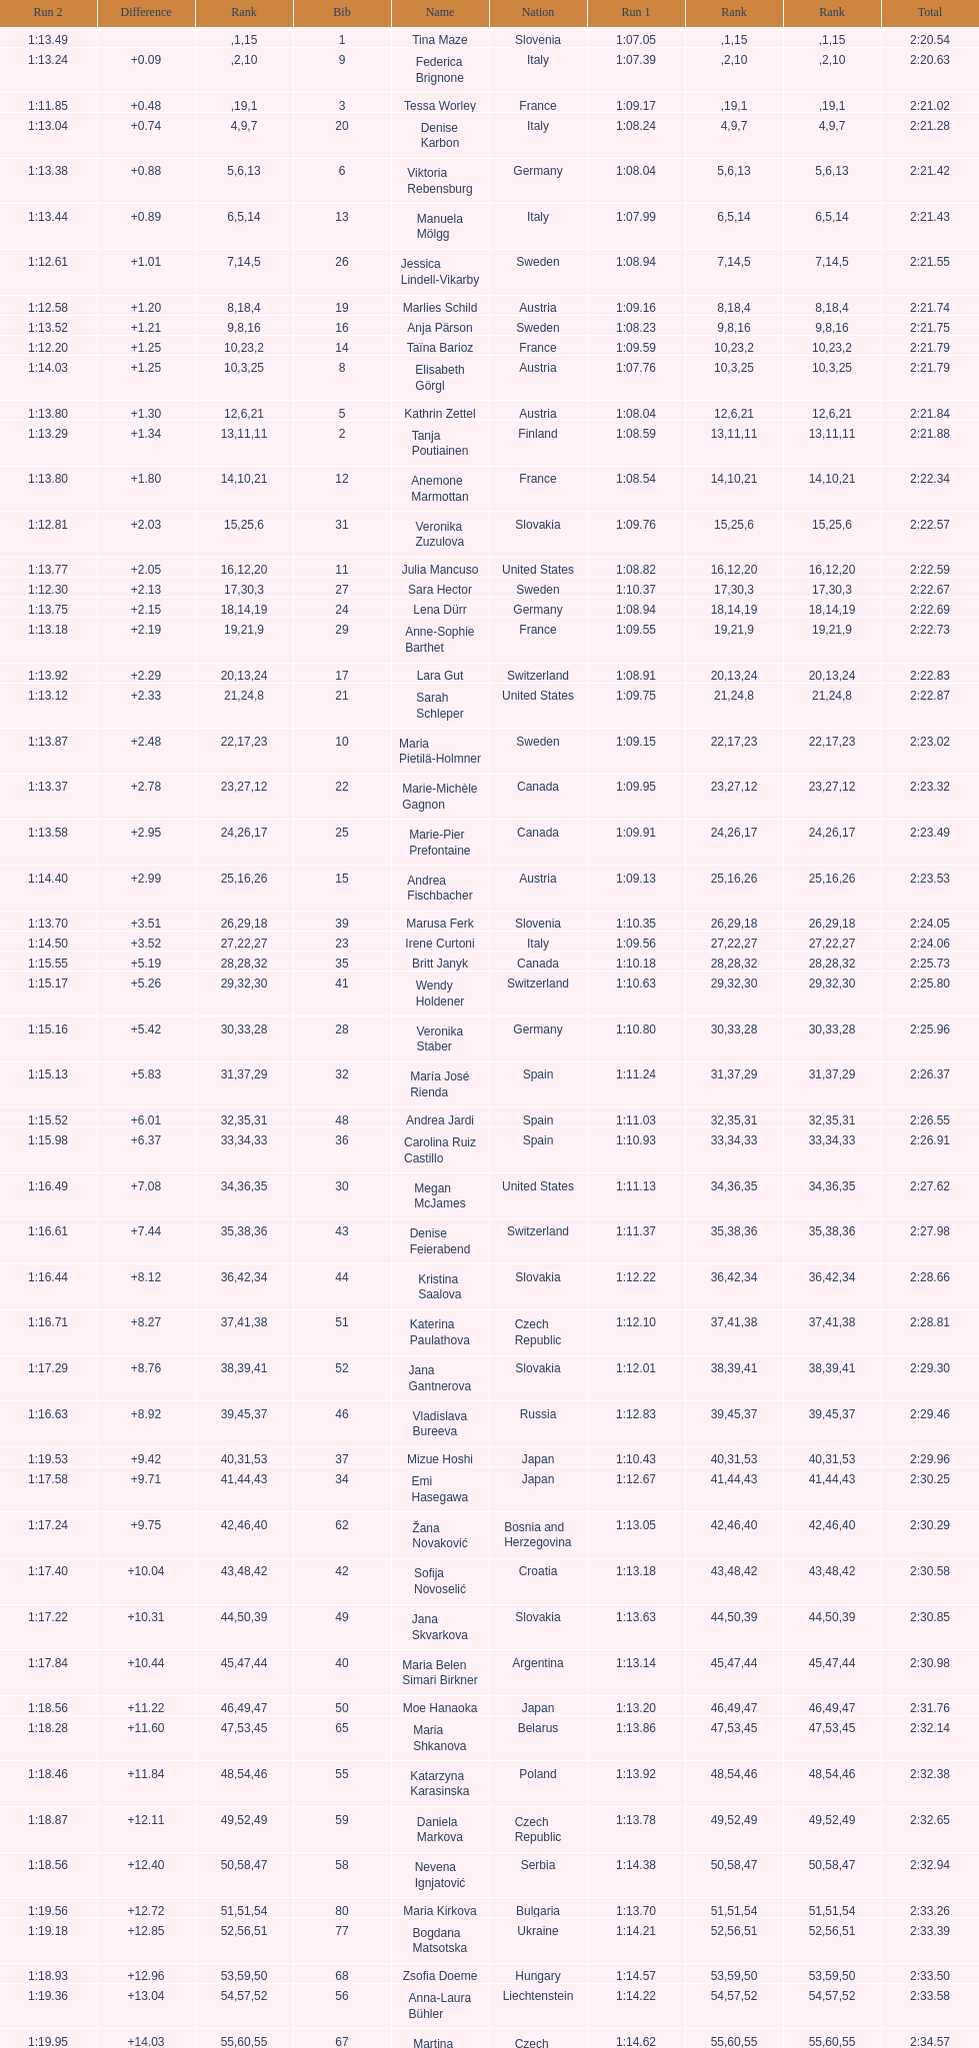What is the last nation to be ranked? Czech Republic. Parse the table in full. {'header': ['Run 2', 'Difference', 'Rank', 'Bib', 'Name', 'Nation', 'Run 1', 'Rank', 'Rank', 'Total'], 'rows': [['1:13.49', '', '', '1', 'Tina Maze', 'Slovenia', '1:07.05', '1', '15', '2:20.54'], ['1:13.24', '+0.09', '', '9', 'Federica Brignone', 'Italy', '1:07.39', '2', '10', '2:20.63'], ['1:11.85', '+0.48', '', '3', 'Tessa Worley', 'France', '1:09.17', '19', '1', '2:21.02'], ['1:13.04', '+0.74', '4', '20', 'Denise Karbon', 'Italy', '1:08.24', '9', '7', '2:21.28'], ['1:13.38', '+0.88', '5', '6', 'Viktoria Rebensburg', 'Germany', '1:08.04', '6', '13', '2:21.42'], ['1:13.44', '+0.89', '6', '13', 'Manuela Mölgg', 'Italy', '1:07.99', '5', '14', '2:21.43'], ['1:12.61', '+1.01', '7', '26', 'Jessica Lindell-Vikarby', 'Sweden', '1:08.94', '14', '5', '2:21.55'], ['1:12.58', '+1.20', '8', '19', 'Marlies Schild', 'Austria', '1:09.16', '18', '4', '2:21.74'], ['1:13.52', '+1.21', '9', '16', 'Anja Pärson', 'Sweden', '1:08.23', '8', '16', '2:21.75'], ['1:12.20', '+1.25', '10', '14', 'Taïna Barioz', 'France', '1:09.59', '23', '2', '2:21.79'], ['1:14.03', '+1.25', '10', '8', 'Elisabeth Görgl', 'Austria', '1:07.76', '3', '25', '2:21.79'], ['1:13.80', '+1.30', '12', '5', 'Kathrin Zettel', 'Austria', '1:08.04', '6', '21', '2:21.84'], ['1:13.29', '+1.34', '13', '2', 'Tanja Poutiainen', 'Finland', '1:08.59', '11', '11', '2:21.88'], ['1:13.80', '+1.80', '14', '12', 'Anemone Marmottan', 'France', '1:08.54', '10', '21', '2:22.34'], ['1:12.81', '+2.03', '15', '31', 'Veronika Zuzulova', 'Slovakia', '1:09.76', '25', '6', '2:22.57'], ['1:13.77', '+2.05', '16', '11', 'Julia Mancuso', 'United States', '1:08.82', '12', '20', '2:22.59'], ['1:12.30', '+2.13', '17', '27', 'Sara Hector', 'Sweden', '1:10.37', '30', '3', '2:22.67'], ['1:13.75', '+2.15', '18', '24', 'Lena Dürr', 'Germany', '1:08.94', '14', '19', '2:22.69'], ['1:13.18', '+2.19', '19', '29', 'Anne-Sophie Barthet', 'France', '1:09.55', '21', '9', '2:22.73'], ['1:13.92', '+2.29', '20', '17', 'Lara Gut', 'Switzerland', '1:08.91', '13', '24', '2:22.83'], ['1:13.12', '+2.33', '21', '21', 'Sarah Schleper', 'United States', '1:09.75', '24', '8', '2:22.87'], ['1:13.87', '+2.48', '22', '10', 'Maria Pietilä-Holmner', 'Sweden', '1:09.15', '17', '23', '2:23.02'], ['1:13.37', '+2.78', '23', '22', 'Marie-Michèle Gagnon', 'Canada', '1:09.95', '27', '12', '2:23.32'], ['1:13.58', '+2.95', '24', '25', 'Marie-Pier Prefontaine', 'Canada', '1:09.91', '26', '17', '2:23.49'], ['1:14.40', '+2.99', '25', '15', 'Andrea Fischbacher', 'Austria', '1:09.13', '16', '26', '2:23.53'], ['1:13.70', '+3.51', '26', '39', 'Marusa Ferk', 'Slovenia', '1:10.35', '29', '18', '2:24.05'], ['1:14.50', '+3.52', '27', '23', 'Irene Curtoni', 'Italy', '1:09.56', '22', '27', '2:24.06'], ['1:15.55', '+5.19', '28', '35', 'Britt Janyk', 'Canada', '1:10.18', '28', '32', '2:25.73'], ['1:15.17', '+5.26', '29', '41', 'Wendy Holdener', 'Switzerland', '1:10.63', '32', '30', '2:25.80'], ['1:15.16', '+5.42', '30', '28', 'Veronika Staber', 'Germany', '1:10.80', '33', '28', '2:25.96'], ['1:15.13', '+5.83', '31', '32', 'María José Rienda', 'Spain', '1:11.24', '37', '29', '2:26.37'], ['1:15.52', '+6.01', '32', '48', 'Andrea Jardi', 'Spain', '1:11.03', '35', '31', '2:26.55'], ['1:15.98', '+6.37', '33', '36', 'Carolina Ruiz Castillo', 'Spain', '1:10.93', '34', '33', '2:26.91'], ['1:16.49', '+7.08', '34', '30', 'Megan McJames', 'United States', '1:11.13', '36', '35', '2:27.62'], ['1:16.61', '+7.44', '35', '43', 'Denise Feierabend', 'Switzerland', '1:11.37', '38', '36', '2:27.98'], ['1:16.44', '+8.12', '36', '44', 'Kristina Saalova', 'Slovakia', '1:12.22', '42', '34', '2:28.66'], ['1:16.71', '+8.27', '37', '51', 'Katerina Paulathova', 'Czech Republic', '1:12.10', '41', '38', '2:28.81'], ['1:17.29', '+8.76', '38', '52', 'Jana Gantnerova', 'Slovakia', '1:12.01', '39', '41', '2:29.30'], ['1:16.63', '+8.92', '39', '46', 'Vladislava Bureeva', 'Russia', '1:12.83', '45', '37', '2:29.46'], ['1:19.53', '+9.42', '40', '37', 'Mizue Hoshi', 'Japan', '1:10.43', '31', '53', '2:29.96'], ['1:17.58', '+9.71', '41', '34', 'Emi Hasegawa', 'Japan', '1:12.67', '44', '43', '2:30.25'], ['1:17.24', '+9.75', '42', '62', 'Žana Novaković', 'Bosnia and Herzegovina', '1:13.05', '46', '40', '2:30.29'], ['1:17.40', '+10.04', '43', '42', 'Sofija Novoselić', 'Croatia', '1:13.18', '48', '42', '2:30.58'], ['1:17.22', '+10.31', '44', '49', 'Jana Skvarkova', 'Slovakia', '1:13.63', '50', '39', '2:30.85'], ['1:17.84', '+10.44', '45', '40', 'Maria Belen Simari Birkner', 'Argentina', '1:13.14', '47', '44', '2:30.98'], ['1:18.56', '+11.22', '46', '50', 'Moe Hanaoka', 'Japan', '1:13.20', '49', '47', '2:31.76'], ['1:18.28', '+11.60', '47', '65', 'Maria Shkanova', 'Belarus', '1:13.86', '53', '45', '2:32.14'], ['1:18.46', '+11.84', '48', '55', 'Katarzyna Karasinska', 'Poland', '1:13.92', '54', '46', '2:32.38'], ['1:18.87', '+12.11', '49', '59', 'Daniela Markova', 'Czech Republic', '1:13.78', '52', '49', '2:32.65'], ['1:18.56', '+12.40', '50', '58', 'Nevena Ignjatović', 'Serbia', '1:14.38', '58', '47', '2:32.94'], ['1:19.56', '+12.72', '51', '80', 'Maria Kirkova', 'Bulgaria', '1:13.70', '51', '54', '2:33.26'], ['1:19.18', '+12.85', '52', '77', 'Bogdana Matsotska', 'Ukraine', '1:14.21', '56', '51', '2:33.39'], ['1:18.93', '+12.96', '53', '68', 'Zsofia Doeme', 'Hungary', '1:14.57', '59', '50', '2:33.50'], ['1:19.36', '+13.04', '54', '56', 'Anna-Laura Bühler', 'Liechtenstein', '1:14.22', '57', '52', '2:33.58'], ['1:19.95', '+14.03', '55', '67', 'Martina Dubovska', 'Czech Republic', '1:14.62', '60', '55', '2:34.57'], ['DNS', '', '', '7', 'Kathrin Hölzl', 'Germany', '1:09.41', '20', '', ''], ['DNF', '', '', '4', 'Maria Riesch', 'Germany', '1:07.86', '4', '', ''], ['DNF', '', '', '38', 'Rebecca Bühler', 'Liechtenstein', '1:12.03', '40', '', ''], ['DNF', '', '', '47', 'Vanessa Schädler', 'Liechtenstein', '1:12.47', '43', '', ''], ['DNF', '', '', '69', 'Iris Gudmundsdottir', 'Iceland', '1:13.93', '55', '', ''], ['DNQ', '', '', '45', 'Tea Palić', 'Croatia', '1:14.73', '61', '', ''], ['DNQ', '', '', '74', 'Macarena Simari Birkner', 'Argentina', '1:15.18', '62', '', ''], ['DNQ', '', '', '72', 'Lavinia Chrystal', 'Australia', '1:15.35', '63', '', ''], ['DNQ', '', '', '81', 'Lelde Gasuna', 'Latvia', '1:15.37', '64', '', ''], ['DNQ', '', '', '64', 'Aleksandra Klus', 'Poland', '1:15.41', '65', '', ''], ['DNQ', '', '', '78', 'Nino Tsiklauri', 'Georgia', '1:15.54', '66', '', ''], ['DNQ', '', '', '66', 'Sarah Jarvis', 'New Zealand', '1:15.94', '67', '', ''], ['DNQ', '', '', '61', 'Anna Berecz', 'Hungary', '1:15.95', '68', '', ''], ['DNQ', '', '', '83', 'Sandra-Elena Narea', 'Romania', '1:16.67', '69', '', ''], ['DNQ', '', '', '85', 'Iulia Petruta Craciun', 'Romania', '1:16.80', '70', '', ''], ['DNQ', '', '', '82', 'Isabel van Buynder', 'Belgium', '1:17.06', '71', '', ''], ['DNQ', '', '', '97', 'Liene Fimbauere', 'Latvia', '1:17.83', '72', '', ''], ['DNQ', '', '', '86', 'Kristina Krone', 'Puerto Rico', '1:17.93', '73', '', ''], ['DNQ', '', '', '88', 'Nicole Valcareggi', 'Greece', '1:18.19', '74', '', ''], ['DNQ', '', '', '100', 'Sophie Fjellvang-Sølling', 'Denmark', '1:18.37', '75', '', ''], ['DNQ', '', '', '95', 'Ornella Oettl Reyes', 'Peru', '1:18.61', '76', '', ''], ['DNQ', '', '', '73', 'Xia Lina', 'China', '1:19.12', '77', '', ''], ['DNQ', '', '', '94', 'Kseniya Grigoreva', 'Uzbekistan', '1:19.16', '78', '', ''], ['DNQ', '', '', '87', 'Tugba Dasdemir', 'Turkey', '1:21.50', '79', '', ''], ['DNQ', '', '', '92', 'Malene Madsen', 'Denmark', '1:22.25', '80', '', ''], ['DNQ', '', '', '84', 'Liu Yang', 'China', '1:22.80', '81', '', ''], ['DNQ', '', '', '91', 'Yom Hirshfeld', 'Israel', '1:22.87', '82', '', ''], ['DNQ', '', '', '75', 'Salome Bancora', 'Argentina', '1:23.08', '83', '', ''], ['DNQ', '', '', '93', 'Ronnie Kiek-Gedalyahu', 'Israel', '1:23.38', '84', '', ''], ['DNQ', '', '', '96', 'Chiara Marano', 'Brazil', '1:24.16', '85', '', ''], ['DNQ', '', '', '113', 'Anne Libak Nielsen', 'Denmark', '1:25.08', '86', '', ''], ['DNQ', '', '', '105', 'Donata Hellner', 'Hungary', '1:26.97', '87', '', ''], ['DNQ', '', '', '102', 'Liu Yu', 'China', '1:27.03', '88', '', ''], ['DNQ', '', '', '109', 'Lida Zvoznikova', 'Kyrgyzstan', '1:27.17', '89', '', ''], ['DNQ', '', '', '103', 'Szelina Hellner', 'Hungary', '1:27.27', '90', '', ''], ['DNQ', '', '', '114', 'Irina Volkova', 'Kyrgyzstan', '1:29.73', '91', '', ''], ['DNQ', '', '', '106', 'Svetlana Baranova', 'Uzbekistan', '1:30.62', '92', '', ''], ['DNQ', '', '', '108', 'Tatjana Baranova', 'Uzbekistan', '1:31.81', '93', '', ''], ['DNQ', '', '', '110', 'Fatemeh Kiadarbandsari', 'Iran', '1:32.16', '94', '', ''], ['DNQ', '', '', '107', 'Ziba Kalhor', 'Iran', '1:32.64', '95', '', ''], ['DNQ', '', '', '104', 'Paraskevi Mavridou', 'Greece', '1:32.83', '96', '', ''], ['DNQ', '', '', '99', 'Marjan Kalhor', 'Iran', '1:34.94', '97', '', ''], ['DNQ', '', '', '112', 'Mitra Kalhor', 'Iran', '1:37.93', '98', '', ''], ['DNQ', '', '', '115', 'Laura Bauer', 'South Africa', '1:42.19', '99', '', ''], ['DNQ', '', '', '111', 'Sarah Ekmekejian', 'Lebanon', '1:42.22', '100', '', ''], ['', '', '', '18', 'Fabienne Suter', 'Switzerland', 'DNS', '', '', ''], ['', '', '', '98', 'Maja Klepić', 'Bosnia and Herzegovina', 'DNS', '', '', ''], ['', '', '', '33', 'Agniezska Gasienica Daniel', 'Poland', 'DNF', '', '', ''], ['', '', '', '53', 'Karolina Chrapek', 'Poland', 'DNF', '', '', ''], ['', '', '', '54', 'Mireia Gutierrez', 'Andorra', 'DNF', '', '', ''], ['', '', '', '57', 'Brittany Phelan', 'Canada', 'DNF', '', '', ''], ['', '', '', '60', 'Tereza Kmochova', 'Czech Republic', 'DNF', '', '', ''], ['', '', '', '63', 'Michelle van Herwerden', 'Netherlands', 'DNF', '', '', ''], ['', '', '', '70', 'Maya Harrisson', 'Brazil', 'DNF', '', '', ''], ['', '', '', '71', 'Elizabeth Pilat', 'Australia', 'DNF', '', '', ''], ['', '', '', '76', 'Katrin Kristjansdottir', 'Iceland', 'DNF', '', '', ''], ['', '', '', '79', 'Julietta Quiroga', 'Argentina', 'DNF', '', '', ''], ['', '', '', '89', 'Evija Benhena', 'Latvia', 'DNF', '', '', ''], ['', '', '', '90', 'Qin Xiyue', 'China', 'DNF', '', '', ''], ['', '', '', '101', 'Sophia Ralli', 'Greece', 'DNF', '', '', ''], ['', '', '', '116', 'Siranush Maghakyan', 'Armenia', 'DNF', '', '', '']]} 